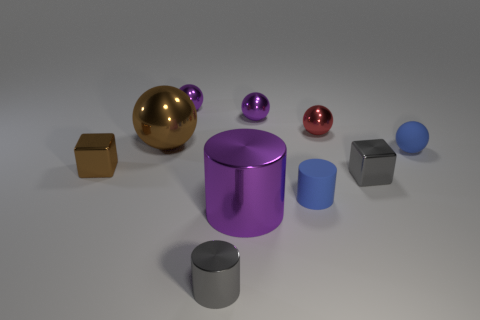Subtract all blue spheres. How many spheres are left? 4 Subtract all big metal balls. How many balls are left? 4 Subtract all green balls. Subtract all green blocks. How many balls are left? 5 Subtract all cubes. How many objects are left? 8 Add 1 tiny cyan cubes. How many tiny cyan cubes exist? 1 Subtract 1 purple cylinders. How many objects are left? 9 Subtract all matte cylinders. Subtract all tiny blue objects. How many objects are left? 7 Add 7 tiny blue rubber cylinders. How many tiny blue rubber cylinders are left? 8 